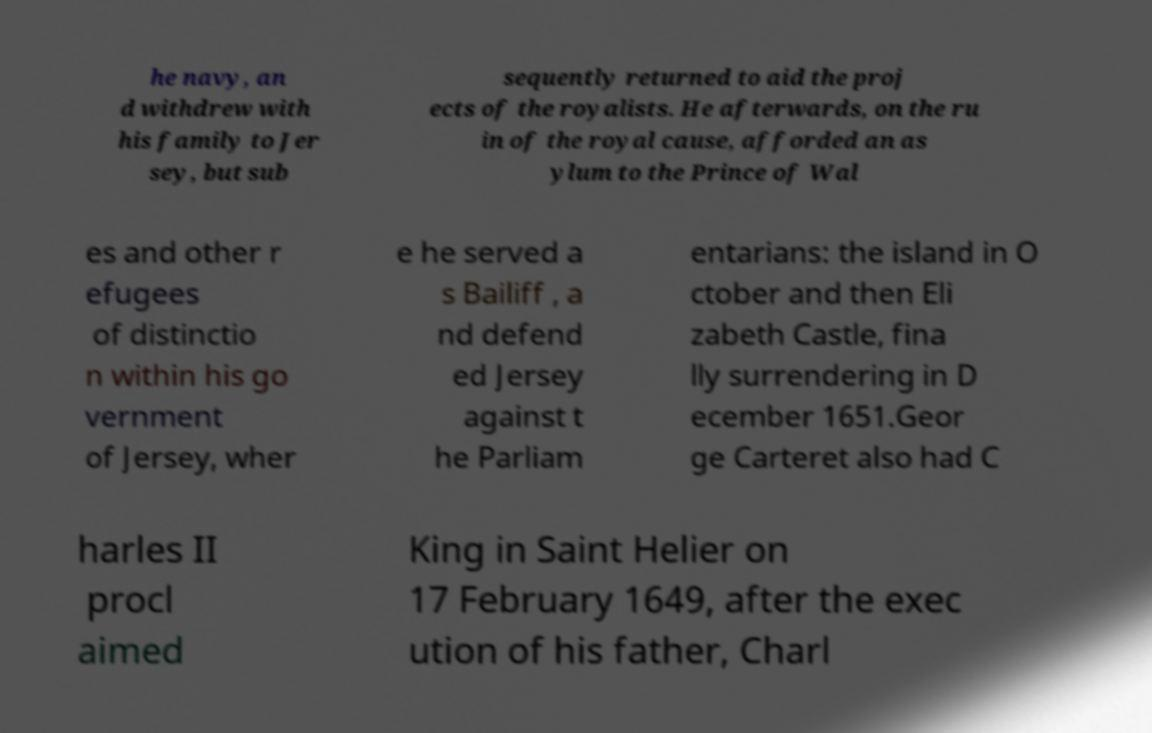I need the written content from this picture converted into text. Can you do that? he navy, an d withdrew with his family to Jer sey, but sub sequently returned to aid the proj ects of the royalists. He afterwards, on the ru in of the royal cause, afforded an as ylum to the Prince of Wal es and other r efugees of distinctio n within his go vernment of Jersey, wher e he served a s Bailiff , a nd defend ed Jersey against t he Parliam entarians: the island in O ctober and then Eli zabeth Castle, fina lly surrendering in D ecember 1651.Geor ge Carteret also had C harles II procl aimed King in Saint Helier on 17 February 1649, after the exec ution of his father, Charl 